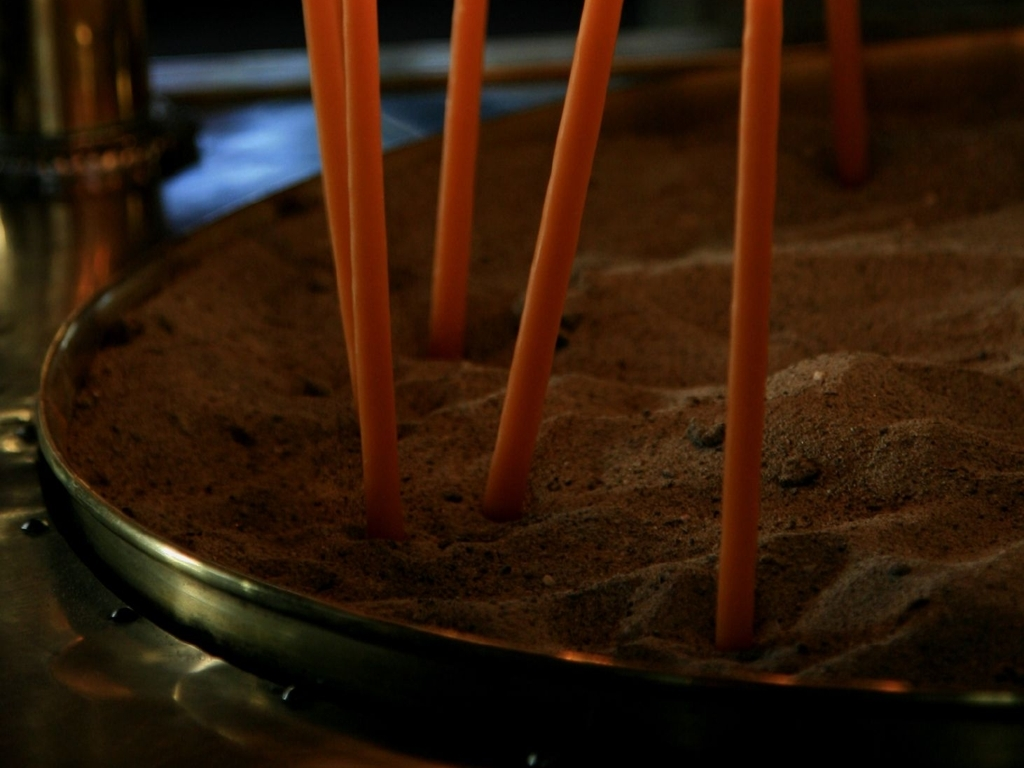Can you describe the setting where this image might have been taken? This image could have been taken in a place designed for tranquility and relaxation, such as a spa, meditation center, or yoga studio. The sandy surface and candles give a sense of grounding and earthiness, while the low lighting suggests a calm, peaceful environment conducive to rest or introspective activities. 